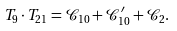<formula> <loc_0><loc_0><loc_500><loc_500>T _ { 9 } \cdot T _ { 2 1 } = \mathcal { C } _ { 1 0 } + \mathcal { C } _ { 1 0 } ^ { \prime } + \mathcal { C } _ { 2 } .</formula> 